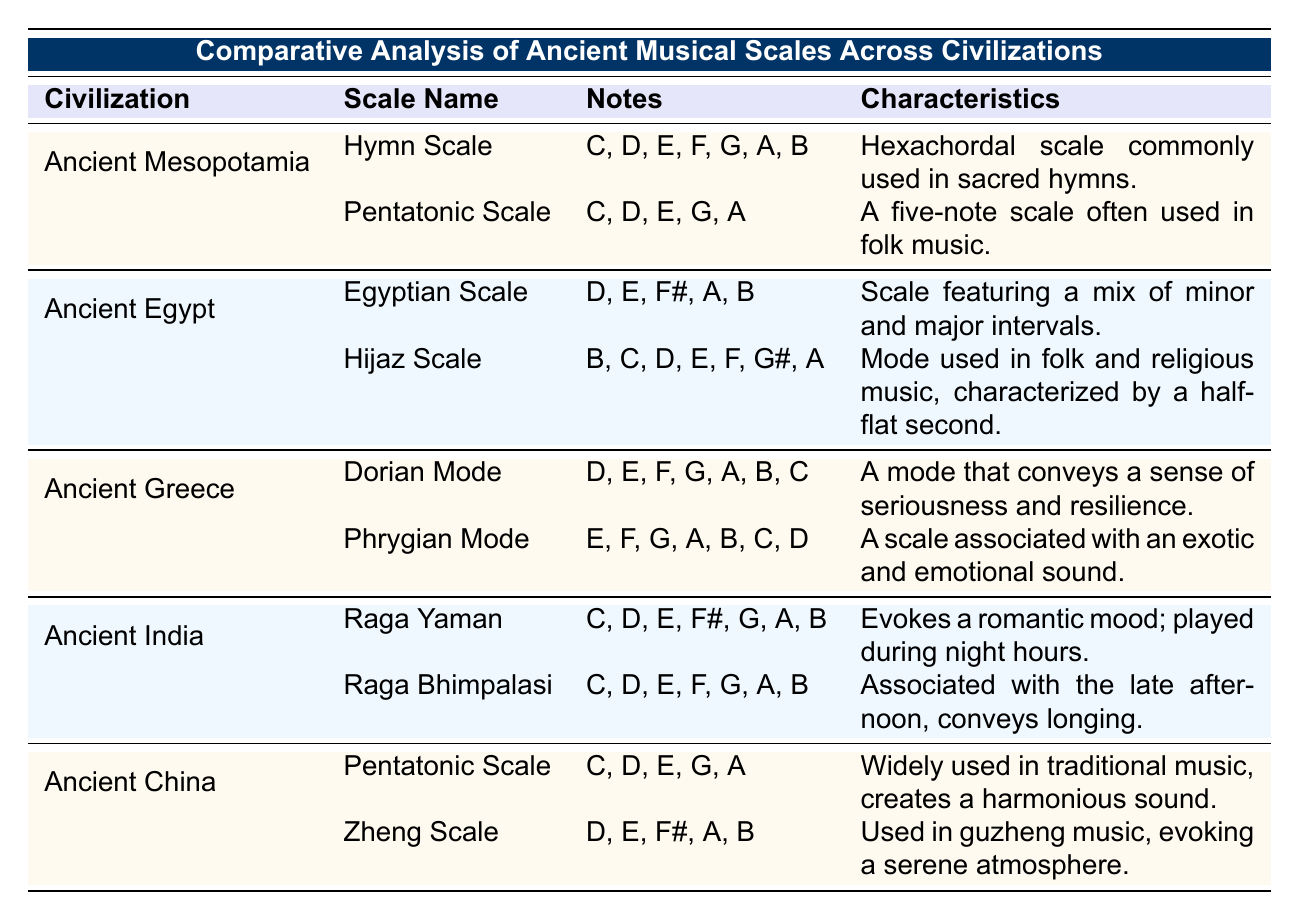What are the notes in the Egyptian Scale? The Egyptian Scale is listed under the Ancient Egypt civilization. Referring to the notes column, the notes in the Egyptian Scale are D, E, F#, A, and B.
Answer: D, E, F#, A, B Which civilization's scale includes a half-flat second? The Hijaz Scale is characterized by a half-flat second. It is listed under the Ancient Egypt civilization in the table.
Answer: Ancient Egypt How many scales are listed for Ancient India? The table shows that there are 2 scales listed for Ancient India: Raga Yaman and Raga Bhimpalasi. Therefore, the count is straightforward.
Answer: 2 Does the Ancient Greek civilization have a scale that conveys a sense of romantic mood? The table lists Dorian Mode and Phrygian Mode for Ancient Greece, but the scale associated with a romantic mood (Raga Yaman) belongs to Ancient India, not Ancient Greece. Therefore, the statement is False.
Answer: No Which ancient civilization's scales utilize the Pentatonic Scale? Both Ancient Mesopotamia and Ancient China have a scale called the Pentatonic Scale. I can see this by referencing both of the entries in the table.
Answer: Ancient Mesopotamia and Ancient China What characteristics define the Raga Bhimpalasi? Looking at the Ancient India row, the Raga Bhimpalasi is described as conveying longing and is associated with the late afternoon. These keywords indicate its emotional and temporal context.
Answer: Conveys longing, associated with late afternoon Compare the number of notes in the Dorian Mode and the Raga Yaman. The Dorian Mode has 7 notes (D, E, F, G, A, B, C), while the Raga Yaman has 7 notes as well (C, D, E, F#, G, A, B). Therefore, when comparing, both have the same number of notes.
Answer: Both have 7 notes Is the Hijaz Scale associated with lively folk music? The Hijaz Scale in the table is described as a mode used in folk and religious music; however, it does not specifically mention being lively, so I conclude the answer is No.
Answer: No What is the characteristic of the Zheng Scale? The Zheng Scale is noted in the Ancient China section, where it is described as evoking a serene atmosphere, indicating a calming quality of this scale.
Answer: Evokes a serene atmosphere Which civilization has scales that utilize the Note E? By checking the list of scales in the table, both Ancient Egypt (Egyptian Scale and Hijaz Scale) and Ancient India (Raga Yaman and Raga Bhimpalasi) feature the note E.
Answer: Ancient Egypt and Ancient India 